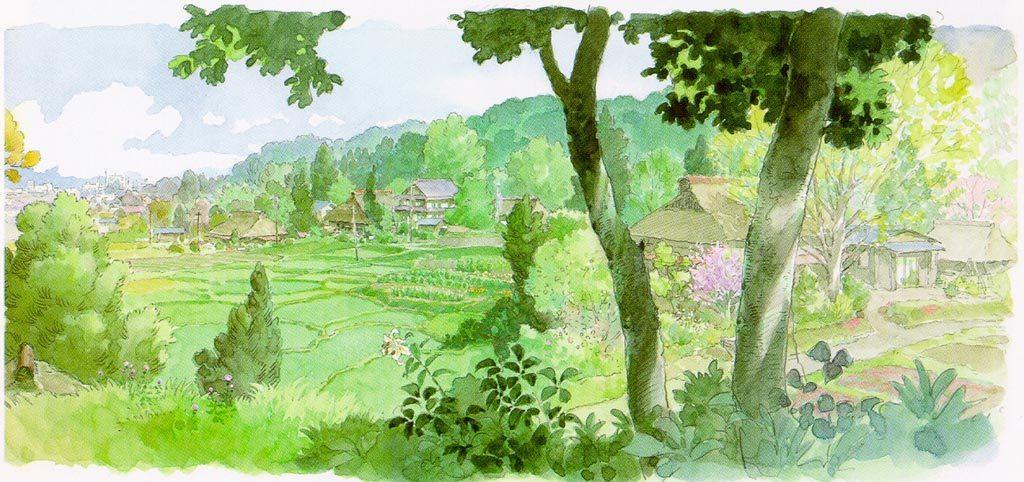Describe this image in one or two sentences. This picture shows painting and we see trees, few houses and clouds in the blue sky. 